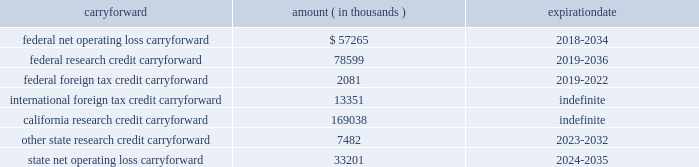Synopsys , inc .
Notes to consolidated financial statements 2014continued the company has the following tax loss and credit carryforwards available to offset future income tax liabilities : carryforward amount expiration ( in thousands ) .
The federal and state net operating loss carryforward is from acquired companies and the annual use of such loss is subject to significant limitations under internal revenue code section 382 .
Foreign tax credits may only be used to offset tax attributable to foreign source income .
The federal research tax credit was permanently reinstated in fiscal 2016 .
The company adopted asu 2016-09 in the first quarter of fiscal 2017 .
The company recorded all income tax effects of share-based awards in its provision for income taxes in the condensed consolidated statement of operations on a prospective basis .
Prior to adoption , the company did not recognize excess tax benefits from stock-based compensation as a charge to capital in excess of par value to the extent that the related tax deduction did not reduce income taxes payable .
Upon adoption of asu 2016-09 , the company recorded a deferred tax asset of $ 106.5 million mainly related to the research tax credit carryover , for the previously unrecognized excess tax benefits with an offsetting adjustment to retained earnings .
Adoption of the new standard resulted in net excess tax benefits in the provision for income taxes of $ 38.1 million for fiscal 2017 .
During the fourth quarter of fiscal 2017 , the company repatriated $ 825 million from its foreign subsidiary .
The repatriation was executed in anticipation of potential u.s .
Corporate tax reform , and the company plans to indefinitely reinvest the remainder of its undistributed foreign earnings outside the united states .
The company provides for u.s .
Income and foreign withholding taxes on foreign earnings , except for foreign earnings that are considered indefinitely reinvested outside the u.s .
As of october 31 , 2017 , there were approximately $ 598.3 million of earnings upon which u.s .
Income taxes of approximately $ 110.0 million have not been provided for. .
What is the differnece between the federal and the state net operating loss carryforward? 
Rationale: it is the variation between those values .
Computations: (57265 - 33201)
Answer: 24064.0. 